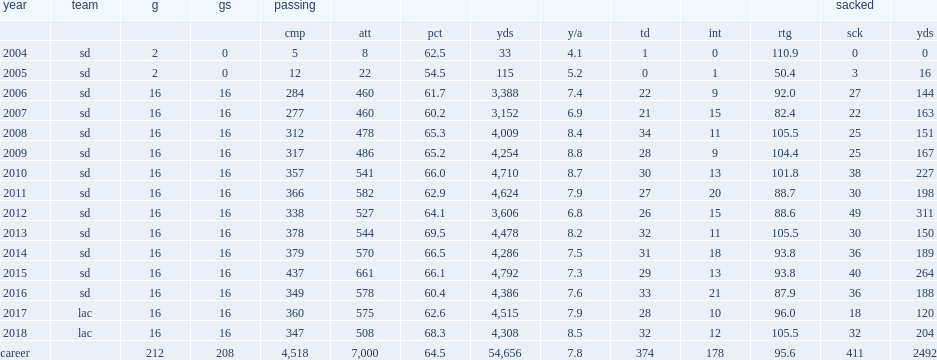How many yards did rivers finish the 2018 season with? 4308.0. How many touchdowns did rivers finish the 2018 season with? 32.0. How many interceptions did rivers finish the 2018 season with? 12.0. 